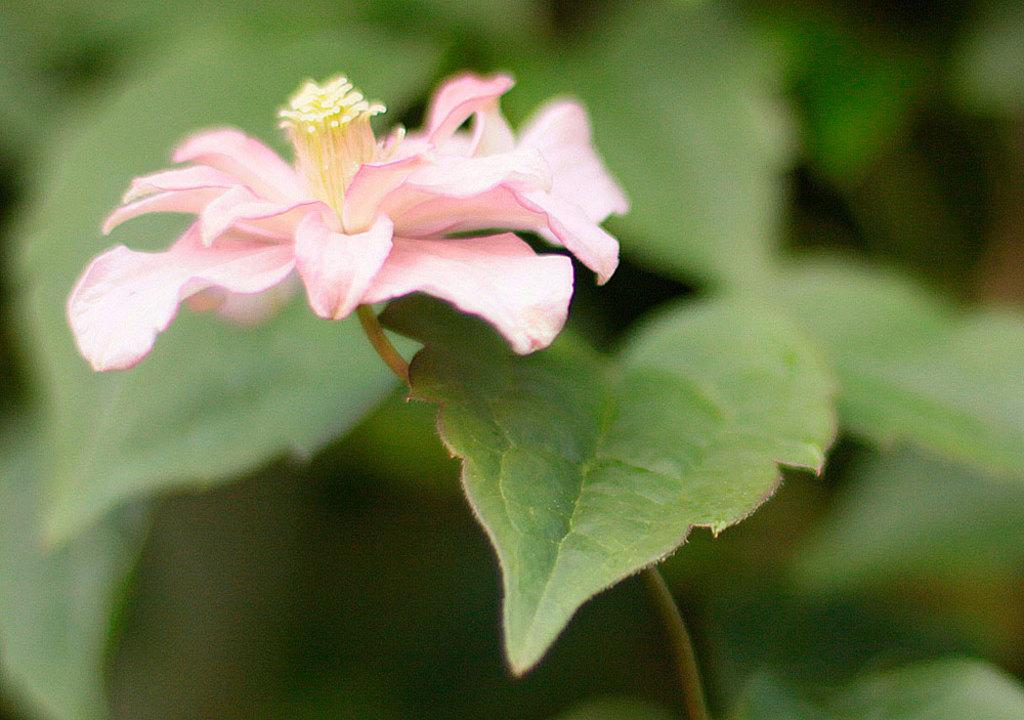What color is the flower in the image? The flower in the image is pink. What other elements are present near the flower? There are green leaves beside the flower. What type of liquid is being used for education in the image? There is no liquid or education-related activity present in the image; it features a pink flower and green leaves. 